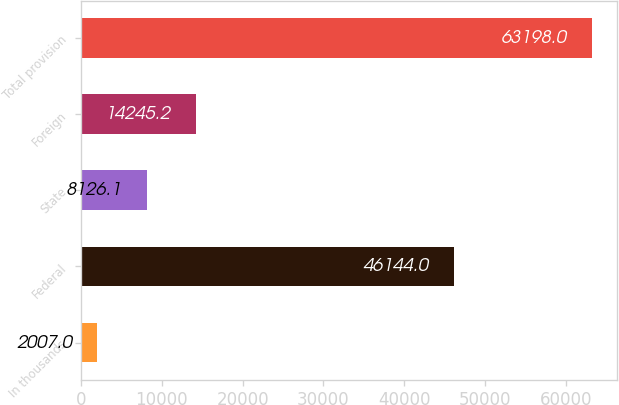<chart> <loc_0><loc_0><loc_500><loc_500><bar_chart><fcel>In thousands<fcel>Federal<fcel>State<fcel>Foreign<fcel>Total provision<nl><fcel>2007<fcel>46144<fcel>8126.1<fcel>14245.2<fcel>63198<nl></chart> 